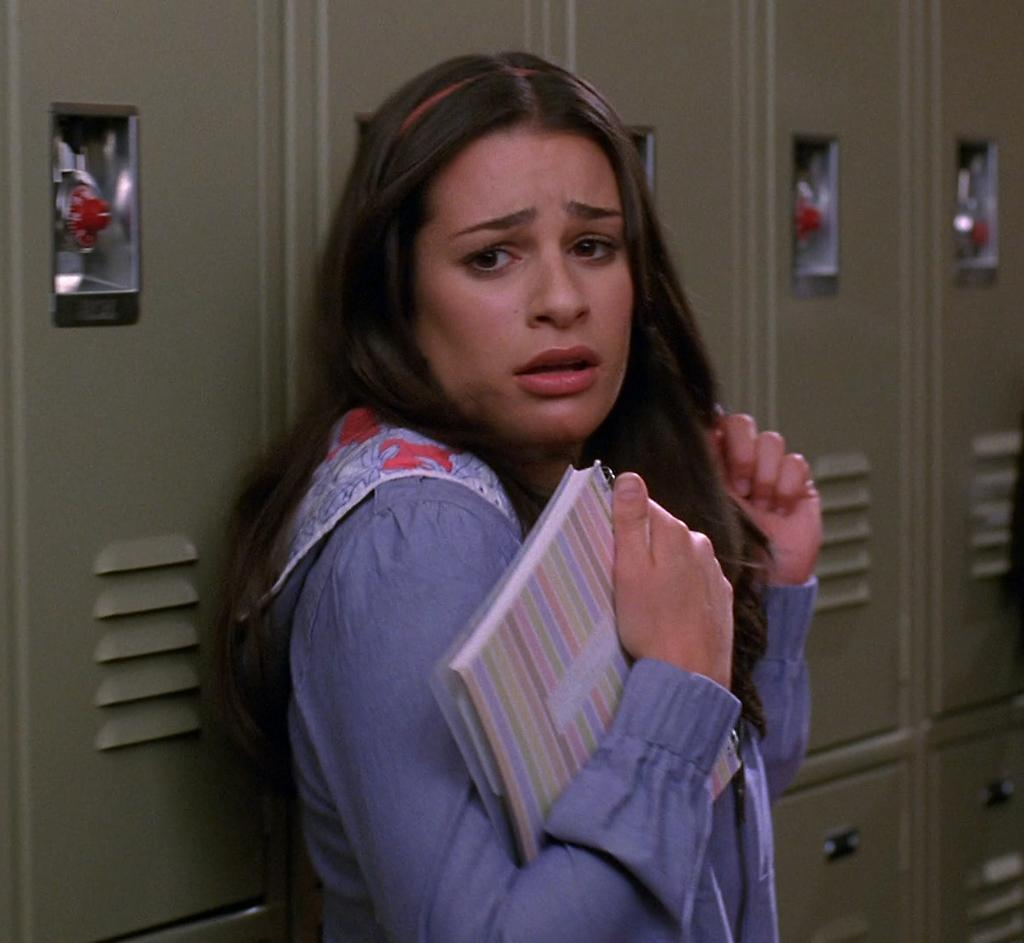Who is the main subject in the picture? There is a girl in the picture. What is the girl wearing? The girl is wearing a blue jacket. What is the girl holding in her hand? The girl is holding a book in her hand. What type of furniture can be seen in the image? There is a grey cupboard visible in the image. What type of paper is the cat using to read the vest in the image? There is no cat or vest present in the image, and therefore no such activity can be observed. 